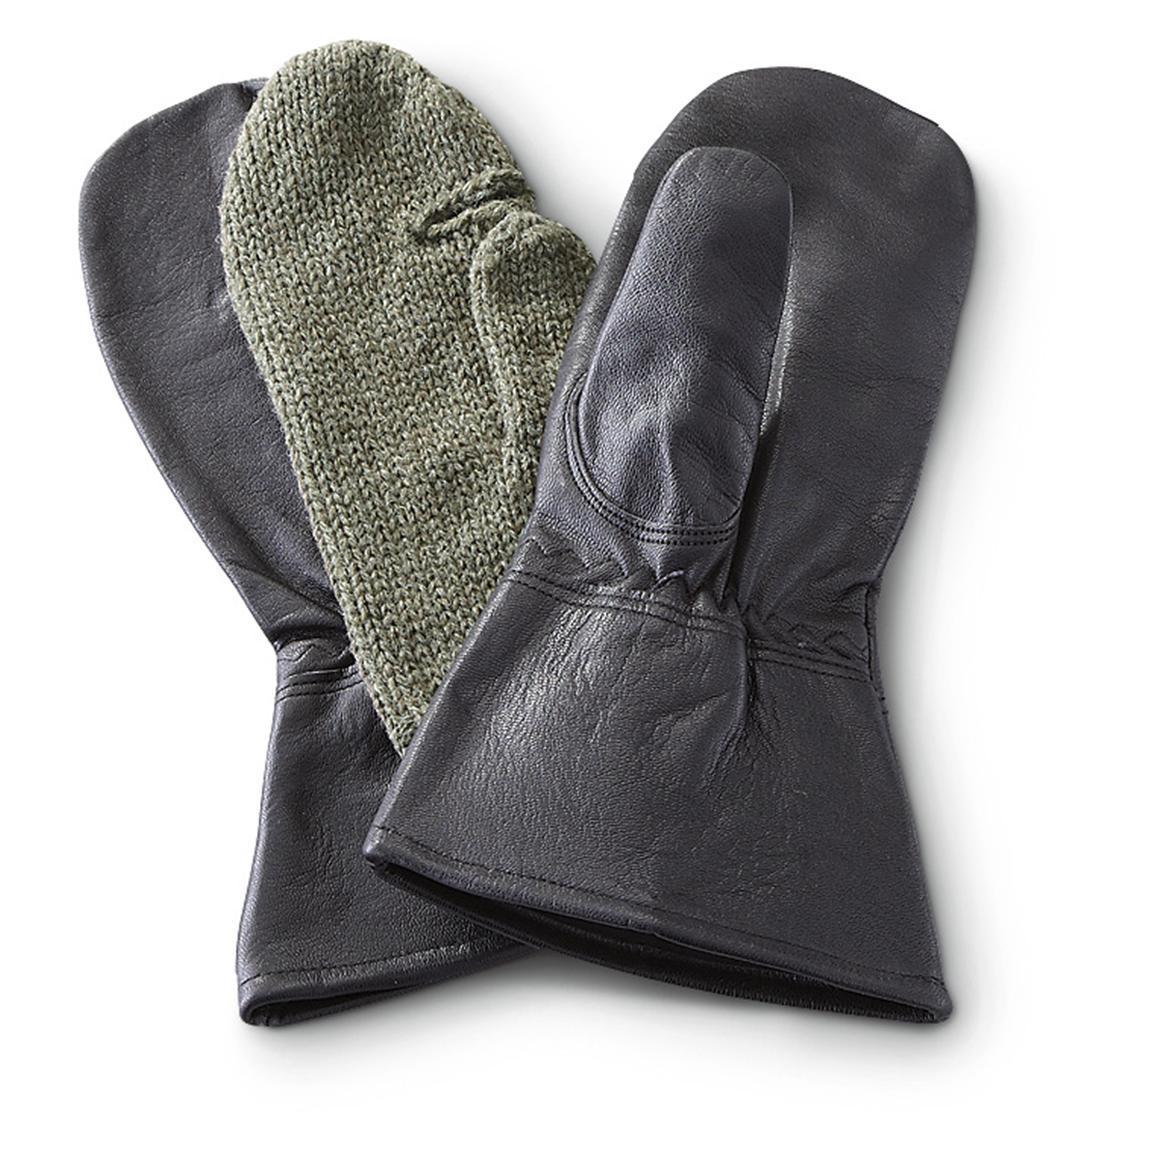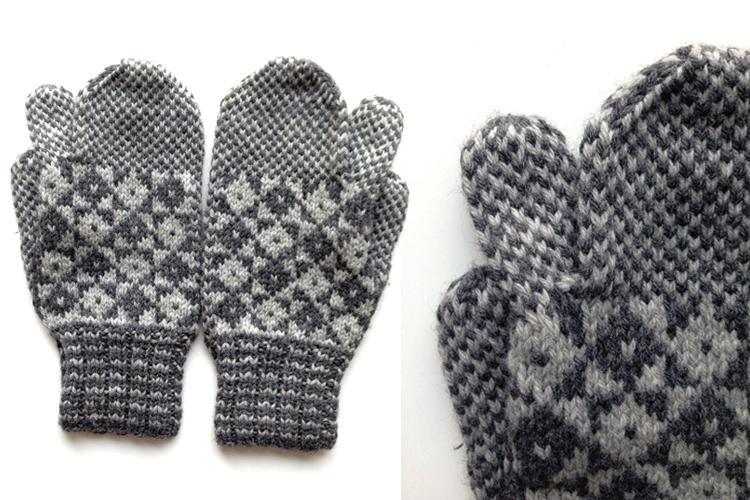The first image is the image on the left, the second image is the image on the right. Analyze the images presented: Is the assertion "Only the right image shows mittens with a diamond pattern." valid? Answer yes or no. Yes. 